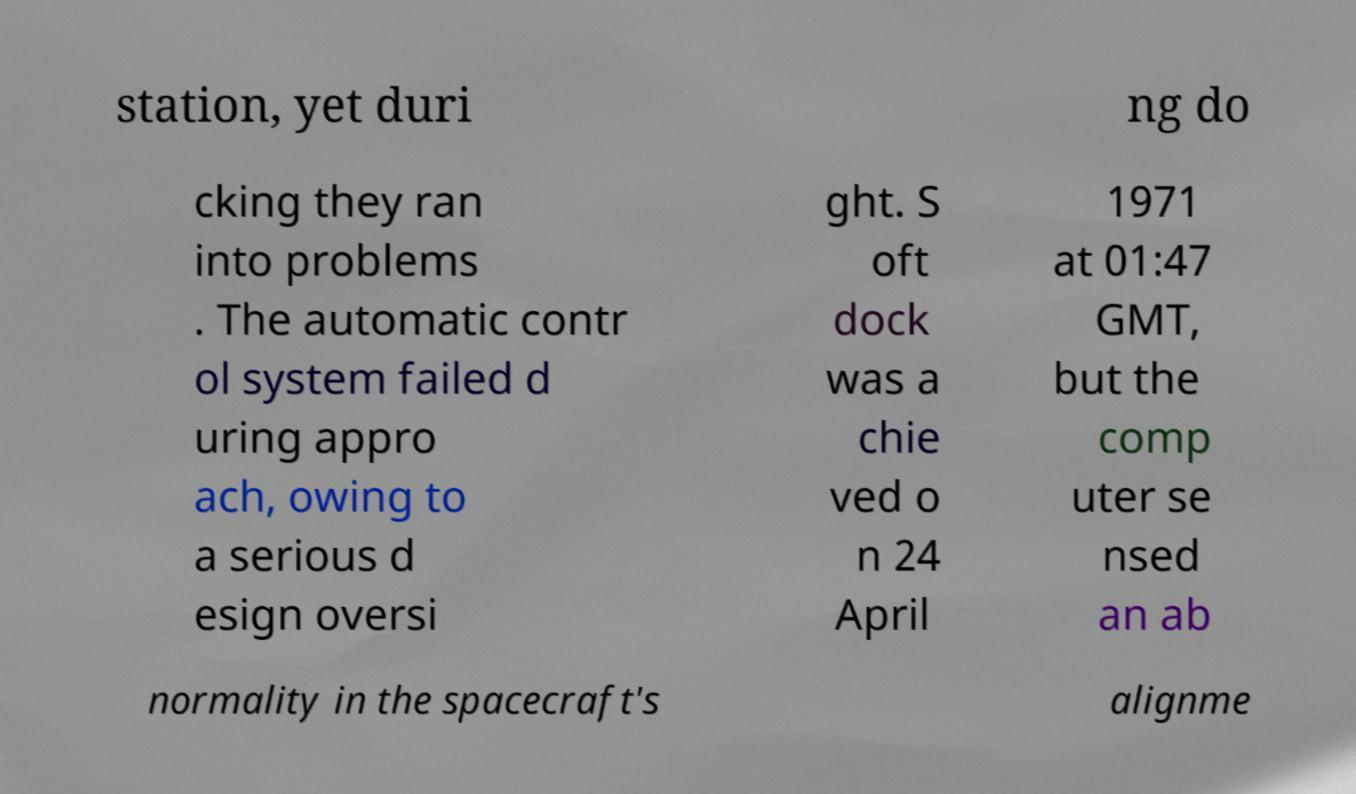Can you accurately transcribe the text from the provided image for me? station, yet duri ng do cking they ran into problems . The automatic contr ol system failed d uring appro ach, owing to a serious d esign oversi ght. S oft dock was a chie ved o n 24 April 1971 at 01:47 GMT, but the comp uter se nsed an ab normality in the spacecraft's alignme 